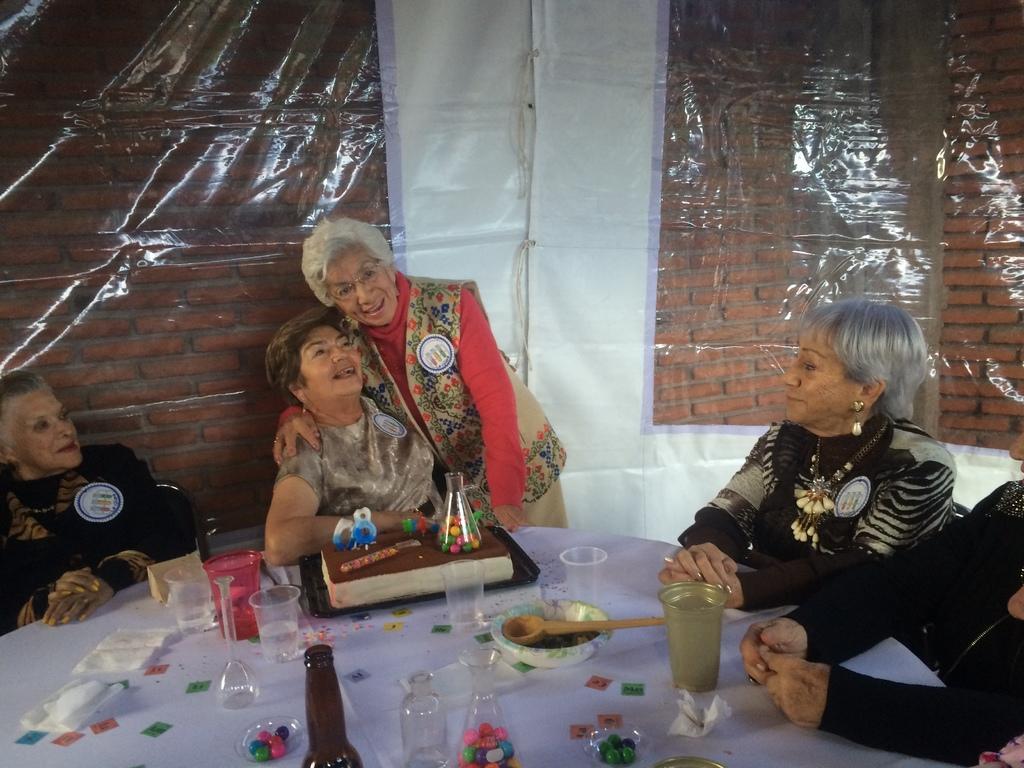Could you give a brief overview of what you see in this image? In this image can see a group of women are sitting in front of a table and a woman standing and smiling. On the table I can see that few bottles and other objects on it. 